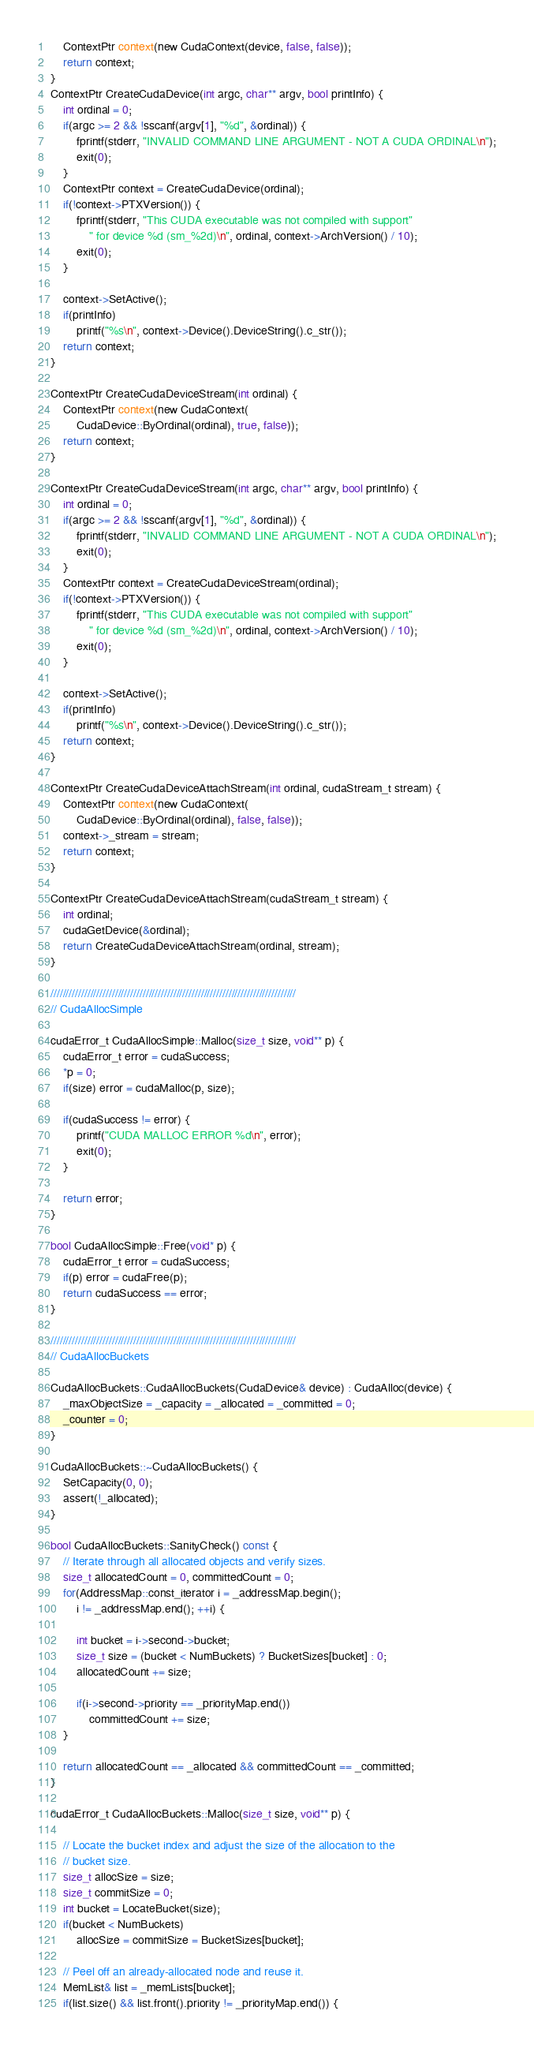<code> <loc_0><loc_0><loc_500><loc_500><_Cuda_>	ContextPtr context(new CudaContext(device, false, false));
	return context;
}
ContextPtr CreateCudaDevice(int argc, char** argv, bool printInfo) {
	int ordinal = 0;
	if(argc >= 2 && !sscanf(argv[1], "%d", &ordinal)) {
		fprintf(stderr, "INVALID COMMAND LINE ARGUMENT - NOT A CUDA ORDINAL\n");
		exit(0);
	}
	ContextPtr context = CreateCudaDevice(ordinal);
	if(!context->PTXVersion()) {
		fprintf(stderr, "This CUDA executable was not compiled with support"
			" for device %d (sm_%2d)\n", ordinal, context->ArchVersion() / 10);
		exit(0);
	}

	context->SetActive();
	if(printInfo)
		printf("%s\n", context->Device().DeviceString().c_str());
	return context;
}

ContextPtr CreateCudaDeviceStream(int ordinal) {
	ContextPtr context(new CudaContext(
		CudaDevice::ByOrdinal(ordinal), true, false));
	return context;
}

ContextPtr CreateCudaDeviceStream(int argc, char** argv, bool printInfo) {
	int ordinal = 0;
	if(argc >= 2 && !sscanf(argv[1], "%d", &ordinal)) {
		fprintf(stderr, "INVALID COMMAND LINE ARGUMENT - NOT A CUDA ORDINAL\n");
		exit(0);
	}
	ContextPtr context = CreateCudaDeviceStream(ordinal);
	if(!context->PTXVersion()) {
		fprintf(stderr, "This CUDA executable was not compiled with support"
			" for device %d (sm_%2d)\n", ordinal, context->ArchVersion() / 10);
		exit(0);
	}

	context->SetActive();
	if(printInfo)
		printf("%s\n", context->Device().DeviceString().c_str());
	return context;
}

ContextPtr CreateCudaDeviceAttachStream(int ordinal, cudaStream_t stream) {
	ContextPtr context(new CudaContext(
		CudaDevice::ByOrdinal(ordinal), false, false));
	context->_stream = stream;
	return context;
}

ContextPtr CreateCudaDeviceAttachStream(cudaStream_t stream) {
	int ordinal;
	cudaGetDevice(&ordinal);
	return CreateCudaDeviceAttachStream(ordinal, stream);
}

////////////////////////////////////////////////////////////////////////////////
// CudaAllocSimple

cudaError_t CudaAllocSimple::Malloc(size_t size, void** p) {
	cudaError_t error = cudaSuccess;
	*p = 0;
	if(size) error = cudaMalloc(p, size);

	if(cudaSuccess != error) {
		printf("CUDA MALLOC ERROR %d\n", error);
		exit(0);
	}

	return error;
}

bool CudaAllocSimple::Free(void* p) {
	cudaError_t error = cudaSuccess;
	if(p) error = cudaFree(p);
	return cudaSuccess == error;
}

////////////////////////////////////////////////////////////////////////////////
// CudaAllocBuckets

CudaAllocBuckets::CudaAllocBuckets(CudaDevice& device) : CudaAlloc(device) {
	_maxObjectSize = _capacity = _allocated = _committed = 0;
	_counter = 0;
}

CudaAllocBuckets::~CudaAllocBuckets() { 
	SetCapacity(0, 0);
	assert(!_allocated);
}

bool CudaAllocBuckets::SanityCheck() const {
	// Iterate through all allocated objects and verify sizes.
	size_t allocatedCount = 0, committedCount = 0;
	for(AddressMap::const_iterator i = _addressMap.begin(); 
		i != _addressMap.end(); ++i) {

		int bucket = i->second->bucket;
		size_t size = (bucket < NumBuckets) ? BucketSizes[bucket] : 0;
		allocatedCount += size;

		if(i->second->priority == _priorityMap.end())
			committedCount += size;
	}

	return allocatedCount == _allocated && committedCount == _committed;
}

cudaError_t CudaAllocBuckets::Malloc(size_t size, void** p) {

	// Locate the bucket index and adjust the size of the allocation to the 
	// bucket size.
	size_t allocSize = size;
	size_t commitSize = 0;
	int bucket = LocateBucket(size);
	if(bucket < NumBuckets)
		allocSize = commitSize = BucketSizes[bucket];

	// Peel off an already-allocated node and reuse it.
	MemList& list = _memLists[bucket];
	if(list.size() && list.front().priority != _priorityMap.end()) {</code> 